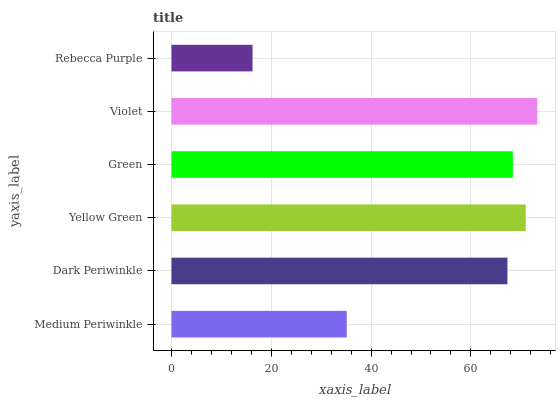Is Rebecca Purple the minimum?
Answer yes or no. Yes. Is Violet the maximum?
Answer yes or no. Yes. Is Dark Periwinkle the minimum?
Answer yes or no. No. Is Dark Periwinkle the maximum?
Answer yes or no. No. Is Dark Periwinkle greater than Medium Periwinkle?
Answer yes or no. Yes. Is Medium Periwinkle less than Dark Periwinkle?
Answer yes or no. Yes. Is Medium Periwinkle greater than Dark Periwinkle?
Answer yes or no. No. Is Dark Periwinkle less than Medium Periwinkle?
Answer yes or no. No. Is Green the high median?
Answer yes or no. Yes. Is Dark Periwinkle the low median?
Answer yes or no. Yes. Is Dark Periwinkle the high median?
Answer yes or no. No. Is Yellow Green the low median?
Answer yes or no. No. 